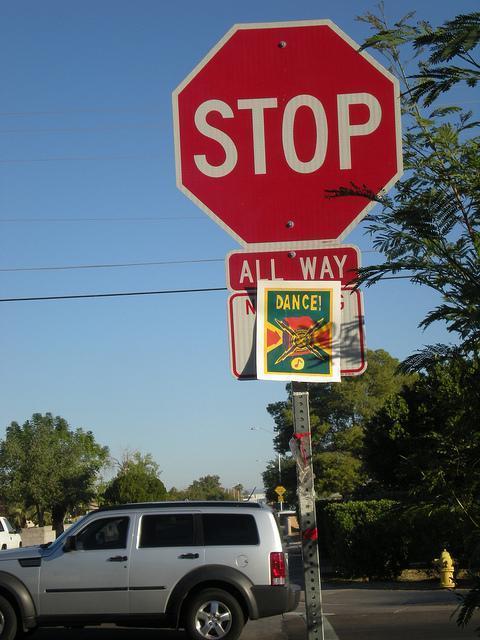How many vehicles can be seen?
Give a very brief answer. 1. How many cars are in the picture?
Give a very brief answer. 1. 